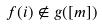<formula> <loc_0><loc_0><loc_500><loc_500>f ( i ) \notin g ( [ m ] )</formula> 